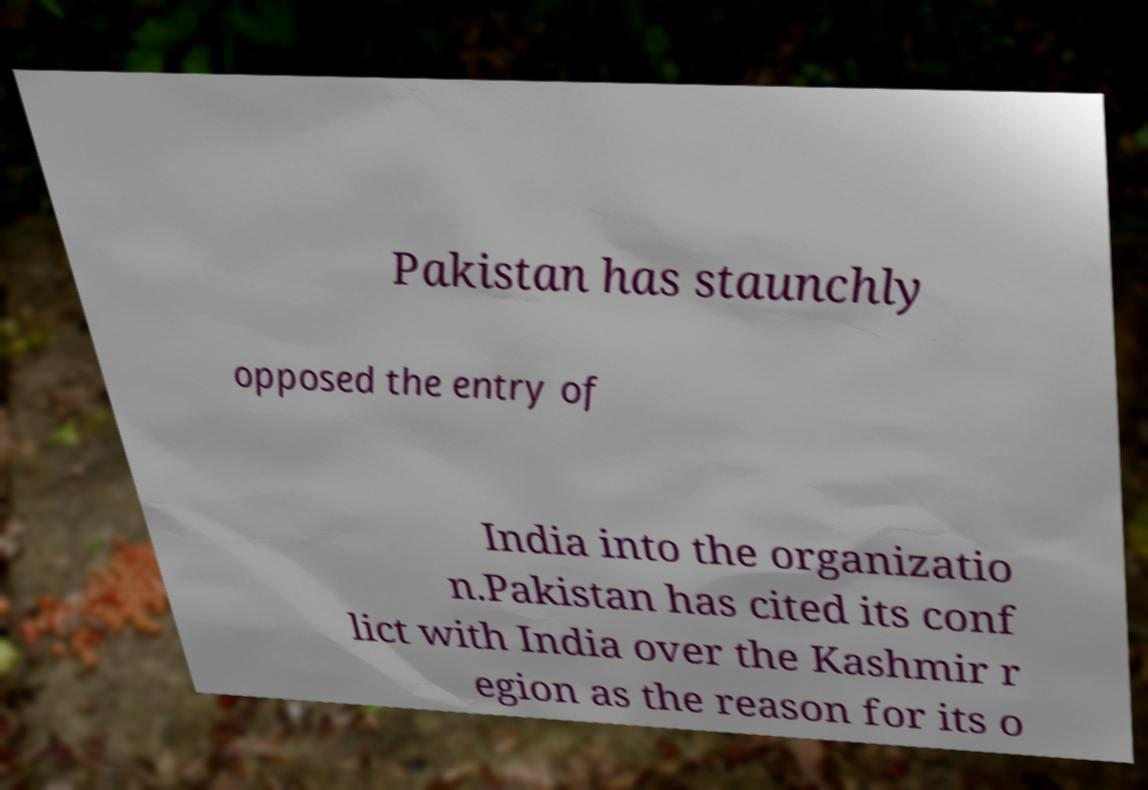What messages or text are displayed in this image? I need them in a readable, typed format. Pakistan has staunchly opposed the entry of India into the organizatio n.Pakistan has cited its conf lict with India over the Kashmir r egion as the reason for its o 